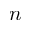Convert formula to latex. <formula><loc_0><loc_0><loc_500><loc_500>n</formula> 